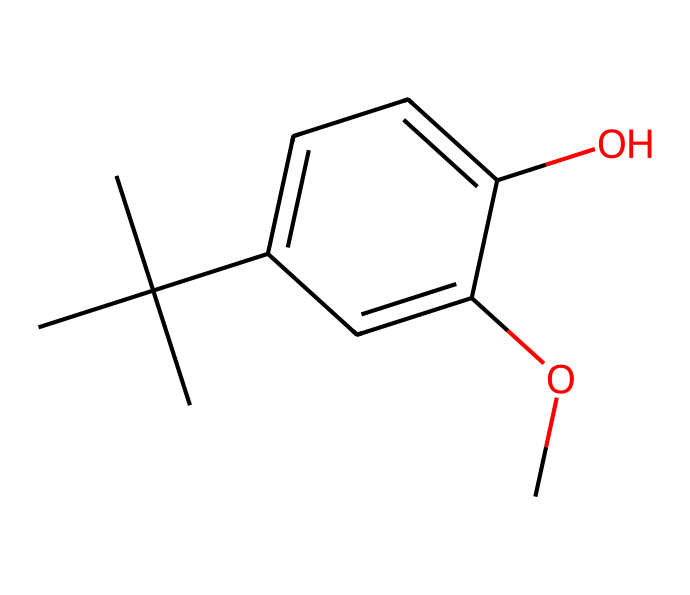What is the molecular formula of butylated hydroxyanisole (BHA)? The molecular formula can be derived from counting the carbon (C), hydrogen (H), and oxygen (O) atoms in the SMILES representation. There are 11 carbon atoms, 14 hydrogen atoms, and 3 oxygen atoms, thus the formula is C11H14O3.
Answer: C11H14O3 How many aromatic rings are present in BHA? The structure contains a distinct aromatic ring, characterized by the presence of double bonds between carbon atoms in a cyclic arrangement. By identifying the cyclic structure within the SMILES, we can confirm there is one aromatic ring.
Answer: 1 What type of functional group is present in BHA? In the SMILES representation, there are -OH and -OCH3 groups present. The -OH group designates a phenolic functional group and the -OCH3 group represents a methoxy group. Thus, BHA contains phenolic and methoxy functional groups.
Answer: phenolic and methoxy What is the total number of oxygen atoms in the BHA structure? From the SMILES, we can identify two -O atoms: one from the -OH (hydroxyl) group and one from the -OCH3 (methoxy) group, resulting in a total count of two oxygen atoms in the structure.
Answer: 3 Which aspect of BHA contributes to its antioxidant properties? The presence of the hydroxyl (-OH) group allows the molecule to donate hydrogen atoms to free radicals, thus stabilizing them and preventing oxidative damage. This is crucial in its role as an antioxidant.
Answer: hydroxyl group What is the effect of the branched structure on BHA's stability? The branched structure, particularly the tert-butyl group which is highly branched, increases steric hindrance and helps in preventing the degradation of the compound, making BHA more stable as an antioxidant in various conditions.
Answer: increases stability 